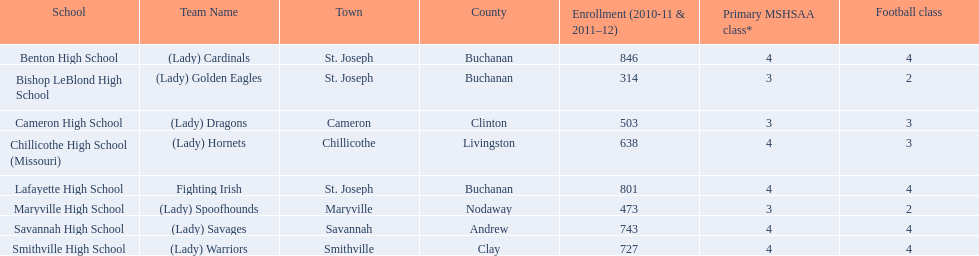How many are enrolled at each school? Benton High School, 846, Bishop LeBlond High School, 314, Cameron High School, 503, Chillicothe High School (Missouri), 638, Lafayette High School, 801, Maryville High School, 473, Savannah High School, 743, Smithville High School, 727. Which school has at only three football classes? Cameron High School, 3, Chillicothe High School (Missouri), 3. Which school has 638 enrolled and 3 football classes? Chillicothe High School (Missouri). 